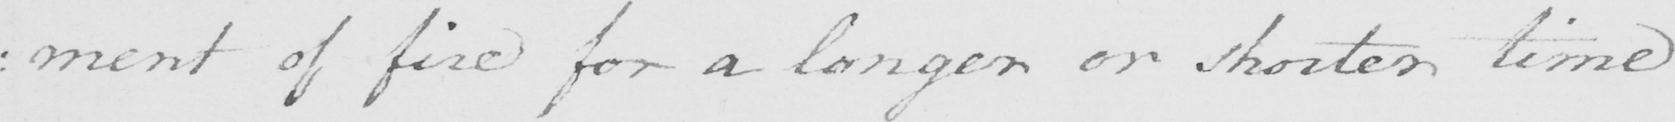Please provide the text content of this handwritten line. : ment of fire for a longer or shorter time 